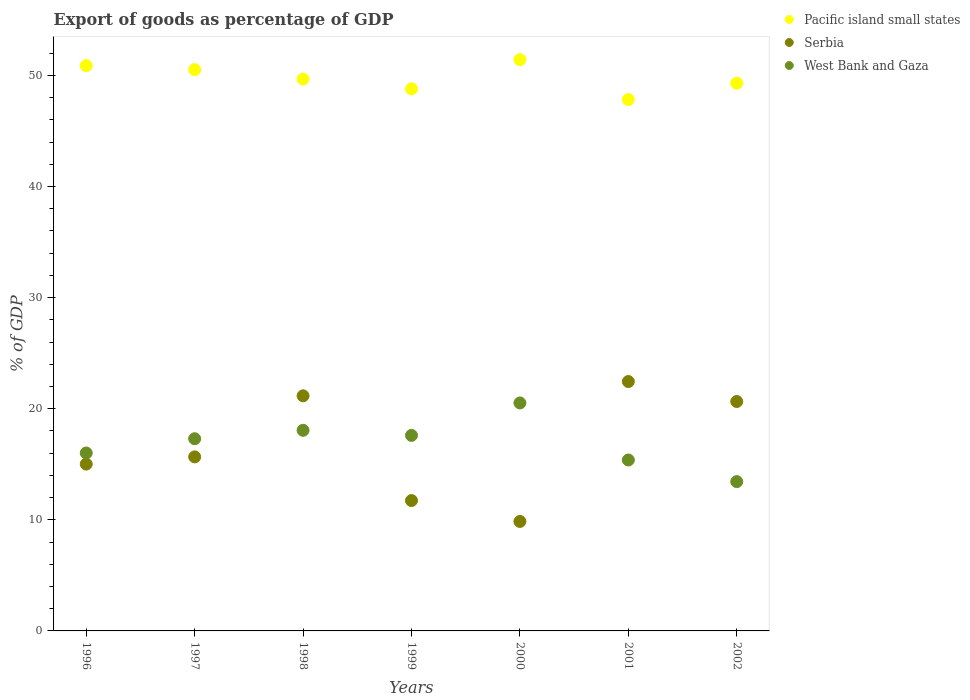How many different coloured dotlines are there?
Make the answer very short. 3. What is the export of goods as percentage of GDP in Pacific island small states in 2002?
Keep it short and to the point. 49.3. Across all years, what is the maximum export of goods as percentage of GDP in Serbia?
Provide a short and direct response. 22.44. Across all years, what is the minimum export of goods as percentage of GDP in West Bank and Gaza?
Ensure brevity in your answer.  13.44. In which year was the export of goods as percentage of GDP in Serbia minimum?
Offer a very short reply. 2000. What is the total export of goods as percentage of GDP in Pacific island small states in the graph?
Your answer should be very brief. 348.36. What is the difference between the export of goods as percentage of GDP in Pacific island small states in 1999 and that in 2001?
Ensure brevity in your answer.  0.96. What is the difference between the export of goods as percentage of GDP in Pacific island small states in 1997 and the export of goods as percentage of GDP in West Bank and Gaza in 1999?
Your answer should be very brief. 32.91. What is the average export of goods as percentage of GDP in West Bank and Gaza per year?
Provide a succinct answer. 16.9. In the year 2002, what is the difference between the export of goods as percentage of GDP in Serbia and export of goods as percentage of GDP in Pacific island small states?
Your answer should be very brief. -28.65. In how many years, is the export of goods as percentage of GDP in Serbia greater than 46 %?
Give a very brief answer. 0. What is the ratio of the export of goods as percentage of GDP in Serbia in 1996 to that in 1999?
Provide a short and direct response. 1.28. What is the difference between the highest and the second highest export of goods as percentage of GDP in Pacific island small states?
Provide a succinct answer. 0.54. What is the difference between the highest and the lowest export of goods as percentage of GDP in Serbia?
Offer a terse response. 12.59. In how many years, is the export of goods as percentage of GDP in West Bank and Gaza greater than the average export of goods as percentage of GDP in West Bank and Gaza taken over all years?
Ensure brevity in your answer.  4. Is it the case that in every year, the sum of the export of goods as percentage of GDP in Serbia and export of goods as percentage of GDP in West Bank and Gaza  is greater than the export of goods as percentage of GDP in Pacific island small states?
Provide a succinct answer. No. How many dotlines are there?
Your answer should be very brief. 3. How many years are there in the graph?
Your answer should be compact. 7. How many legend labels are there?
Make the answer very short. 3. What is the title of the graph?
Offer a very short reply. Export of goods as percentage of GDP. Does "Congo (Republic)" appear as one of the legend labels in the graph?
Your answer should be compact. No. What is the label or title of the Y-axis?
Give a very brief answer. % of GDP. What is the % of GDP in Pacific island small states in 1996?
Make the answer very short. 50.87. What is the % of GDP in Serbia in 1996?
Provide a short and direct response. 15.01. What is the % of GDP of West Bank and Gaza in 1996?
Offer a very short reply. 16.01. What is the % of GDP of Pacific island small states in 1997?
Give a very brief answer. 50.51. What is the % of GDP in Serbia in 1997?
Offer a terse response. 15.66. What is the % of GDP in West Bank and Gaza in 1997?
Give a very brief answer. 17.3. What is the % of GDP of Pacific island small states in 1998?
Keep it short and to the point. 49.67. What is the % of GDP of Serbia in 1998?
Keep it short and to the point. 21.16. What is the % of GDP in West Bank and Gaza in 1998?
Offer a terse response. 18.05. What is the % of GDP in Pacific island small states in 1999?
Make the answer very short. 48.78. What is the % of GDP in Serbia in 1999?
Your answer should be compact. 11.73. What is the % of GDP in West Bank and Gaza in 1999?
Keep it short and to the point. 17.6. What is the % of GDP in Pacific island small states in 2000?
Give a very brief answer. 51.41. What is the % of GDP in Serbia in 2000?
Offer a very short reply. 9.85. What is the % of GDP in West Bank and Gaza in 2000?
Offer a terse response. 20.52. What is the % of GDP in Pacific island small states in 2001?
Offer a terse response. 47.82. What is the % of GDP in Serbia in 2001?
Keep it short and to the point. 22.44. What is the % of GDP of West Bank and Gaza in 2001?
Provide a short and direct response. 15.38. What is the % of GDP in Pacific island small states in 2002?
Ensure brevity in your answer.  49.3. What is the % of GDP in Serbia in 2002?
Your answer should be compact. 20.65. What is the % of GDP in West Bank and Gaza in 2002?
Ensure brevity in your answer.  13.44. Across all years, what is the maximum % of GDP in Pacific island small states?
Your answer should be very brief. 51.41. Across all years, what is the maximum % of GDP in Serbia?
Provide a short and direct response. 22.44. Across all years, what is the maximum % of GDP in West Bank and Gaza?
Ensure brevity in your answer.  20.52. Across all years, what is the minimum % of GDP in Pacific island small states?
Give a very brief answer. 47.82. Across all years, what is the minimum % of GDP of Serbia?
Keep it short and to the point. 9.85. Across all years, what is the minimum % of GDP of West Bank and Gaza?
Give a very brief answer. 13.44. What is the total % of GDP in Pacific island small states in the graph?
Your answer should be compact. 348.36. What is the total % of GDP in Serbia in the graph?
Provide a succinct answer. 116.51. What is the total % of GDP of West Bank and Gaza in the graph?
Make the answer very short. 118.3. What is the difference between the % of GDP of Pacific island small states in 1996 and that in 1997?
Offer a very short reply. 0.36. What is the difference between the % of GDP in Serbia in 1996 and that in 1997?
Ensure brevity in your answer.  -0.65. What is the difference between the % of GDP of West Bank and Gaza in 1996 and that in 1997?
Your answer should be compact. -1.28. What is the difference between the % of GDP in Pacific island small states in 1996 and that in 1998?
Your answer should be very brief. 1.21. What is the difference between the % of GDP in Serbia in 1996 and that in 1998?
Your answer should be compact. -6.14. What is the difference between the % of GDP in West Bank and Gaza in 1996 and that in 1998?
Your answer should be compact. -2.04. What is the difference between the % of GDP in Pacific island small states in 1996 and that in 1999?
Your answer should be very brief. 2.09. What is the difference between the % of GDP of Serbia in 1996 and that in 1999?
Make the answer very short. 3.28. What is the difference between the % of GDP in West Bank and Gaza in 1996 and that in 1999?
Provide a succinct answer. -1.58. What is the difference between the % of GDP in Pacific island small states in 1996 and that in 2000?
Your answer should be compact. -0.54. What is the difference between the % of GDP in Serbia in 1996 and that in 2000?
Provide a succinct answer. 5.16. What is the difference between the % of GDP in West Bank and Gaza in 1996 and that in 2000?
Make the answer very short. -4.5. What is the difference between the % of GDP of Pacific island small states in 1996 and that in 2001?
Provide a succinct answer. 3.05. What is the difference between the % of GDP in Serbia in 1996 and that in 2001?
Ensure brevity in your answer.  -7.43. What is the difference between the % of GDP of West Bank and Gaza in 1996 and that in 2001?
Give a very brief answer. 0.63. What is the difference between the % of GDP of Pacific island small states in 1996 and that in 2002?
Your response must be concise. 1.57. What is the difference between the % of GDP of Serbia in 1996 and that in 2002?
Your answer should be compact. -5.63. What is the difference between the % of GDP of West Bank and Gaza in 1996 and that in 2002?
Make the answer very short. 2.58. What is the difference between the % of GDP of Pacific island small states in 1997 and that in 1998?
Make the answer very short. 0.85. What is the difference between the % of GDP in Serbia in 1997 and that in 1998?
Provide a short and direct response. -5.5. What is the difference between the % of GDP of West Bank and Gaza in 1997 and that in 1998?
Offer a terse response. -0.76. What is the difference between the % of GDP in Pacific island small states in 1997 and that in 1999?
Your answer should be compact. 1.73. What is the difference between the % of GDP of Serbia in 1997 and that in 1999?
Offer a very short reply. 3.93. What is the difference between the % of GDP of West Bank and Gaza in 1997 and that in 1999?
Keep it short and to the point. -0.3. What is the difference between the % of GDP of Pacific island small states in 1997 and that in 2000?
Ensure brevity in your answer.  -0.9. What is the difference between the % of GDP of Serbia in 1997 and that in 2000?
Your answer should be compact. 5.81. What is the difference between the % of GDP in West Bank and Gaza in 1997 and that in 2000?
Ensure brevity in your answer.  -3.22. What is the difference between the % of GDP of Pacific island small states in 1997 and that in 2001?
Provide a short and direct response. 2.69. What is the difference between the % of GDP of Serbia in 1997 and that in 2001?
Offer a very short reply. -6.78. What is the difference between the % of GDP in West Bank and Gaza in 1997 and that in 2001?
Ensure brevity in your answer.  1.91. What is the difference between the % of GDP in Pacific island small states in 1997 and that in 2002?
Your response must be concise. 1.21. What is the difference between the % of GDP in Serbia in 1997 and that in 2002?
Provide a succinct answer. -4.98. What is the difference between the % of GDP of West Bank and Gaza in 1997 and that in 2002?
Your response must be concise. 3.86. What is the difference between the % of GDP in Pacific island small states in 1998 and that in 1999?
Your response must be concise. 0.88. What is the difference between the % of GDP in Serbia in 1998 and that in 1999?
Give a very brief answer. 9.43. What is the difference between the % of GDP of West Bank and Gaza in 1998 and that in 1999?
Make the answer very short. 0.46. What is the difference between the % of GDP in Pacific island small states in 1998 and that in 2000?
Provide a short and direct response. -1.74. What is the difference between the % of GDP of Serbia in 1998 and that in 2000?
Keep it short and to the point. 11.3. What is the difference between the % of GDP in West Bank and Gaza in 1998 and that in 2000?
Ensure brevity in your answer.  -2.46. What is the difference between the % of GDP of Pacific island small states in 1998 and that in 2001?
Make the answer very short. 1.85. What is the difference between the % of GDP of Serbia in 1998 and that in 2001?
Provide a short and direct response. -1.29. What is the difference between the % of GDP of West Bank and Gaza in 1998 and that in 2001?
Your answer should be very brief. 2.67. What is the difference between the % of GDP in Pacific island small states in 1998 and that in 2002?
Give a very brief answer. 0.37. What is the difference between the % of GDP in Serbia in 1998 and that in 2002?
Make the answer very short. 0.51. What is the difference between the % of GDP of West Bank and Gaza in 1998 and that in 2002?
Ensure brevity in your answer.  4.62. What is the difference between the % of GDP in Pacific island small states in 1999 and that in 2000?
Your answer should be compact. -2.63. What is the difference between the % of GDP of Serbia in 1999 and that in 2000?
Offer a terse response. 1.88. What is the difference between the % of GDP in West Bank and Gaza in 1999 and that in 2000?
Make the answer very short. -2.92. What is the difference between the % of GDP of Pacific island small states in 1999 and that in 2001?
Provide a short and direct response. 0.96. What is the difference between the % of GDP of Serbia in 1999 and that in 2001?
Make the answer very short. -10.71. What is the difference between the % of GDP in West Bank and Gaza in 1999 and that in 2001?
Make the answer very short. 2.21. What is the difference between the % of GDP of Pacific island small states in 1999 and that in 2002?
Your answer should be compact. -0.51. What is the difference between the % of GDP in Serbia in 1999 and that in 2002?
Provide a succinct answer. -8.91. What is the difference between the % of GDP in West Bank and Gaza in 1999 and that in 2002?
Keep it short and to the point. 4.16. What is the difference between the % of GDP of Pacific island small states in 2000 and that in 2001?
Provide a short and direct response. 3.59. What is the difference between the % of GDP of Serbia in 2000 and that in 2001?
Provide a succinct answer. -12.59. What is the difference between the % of GDP of West Bank and Gaza in 2000 and that in 2001?
Offer a terse response. 5.13. What is the difference between the % of GDP in Pacific island small states in 2000 and that in 2002?
Provide a short and direct response. 2.11. What is the difference between the % of GDP in Serbia in 2000 and that in 2002?
Provide a short and direct response. -10.79. What is the difference between the % of GDP of West Bank and Gaza in 2000 and that in 2002?
Offer a very short reply. 7.08. What is the difference between the % of GDP in Pacific island small states in 2001 and that in 2002?
Your answer should be very brief. -1.48. What is the difference between the % of GDP in Serbia in 2001 and that in 2002?
Ensure brevity in your answer.  1.8. What is the difference between the % of GDP of West Bank and Gaza in 2001 and that in 2002?
Your answer should be very brief. 1.95. What is the difference between the % of GDP of Pacific island small states in 1996 and the % of GDP of Serbia in 1997?
Your answer should be compact. 35.21. What is the difference between the % of GDP of Pacific island small states in 1996 and the % of GDP of West Bank and Gaza in 1997?
Your answer should be very brief. 33.58. What is the difference between the % of GDP of Serbia in 1996 and the % of GDP of West Bank and Gaza in 1997?
Keep it short and to the point. -2.28. What is the difference between the % of GDP of Pacific island small states in 1996 and the % of GDP of Serbia in 1998?
Your response must be concise. 29.71. What is the difference between the % of GDP in Pacific island small states in 1996 and the % of GDP in West Bank and Gaza in 1998?
Give a very brief answer. 32.82. What is the difference between the % of GDP of Serbia in 1996 and the % of GDP of West Bank and Gaza in 1998?
Your answer should be very brief. -3.04. What is the difference between the % of GDP of Pacific island small states in 1996 and the % of GDP of Serbia in 1999?
Ensure brevity in your answer.  39.14. What is the difference between the % of GDP in Pacific island small states in 1996 and the % of GDP in West Bank and Gaza in 1999?
Ensure brevity in your answer.  33.27. What is the difference between the % of GDP of Serbia in 1996 and the % of GDP of West Bank and Gaza in 1999?
Your answer should be compact. -2.58. What is the difference between the % of GDP of Pacific island small states in 1996 and the % of GDP of Serbia in 2000?
Offer a very short reply. 41.02. What is the difference between the % of GDP of Pacific island small states in 1996 and the % of GDP of West Bank and Gaza in 2000?
Your answer should be compact. 30.36. What is the difference between the % of GDP of Serbia in 1996 and the % of GDP of West Bank and Gaza in 2000?
Give a very brief answer. -5.5. What is the difference between the % of GDP of Pacific island small states in 1996 and the % of GDP of Serbia in 2001?
Your answer should be very brief. 28.43. What is the difference between the % of GDP of Pacific island small states in 1996 and the % of GDP of West Bank and Gaza in 2001?
Your answer should be compact. 35.49. What is the difference between the % of GDP in Serbia in 1996 and the % of GDP in West Bank and Gaza in 2001?
Your answer should be compact. -0.37. What is the difference between the % of GDP in Pacific island small states in 1996 and the % of GDP in Serbia in 2002?
Your response must be concise. 30.23. What is the difference between the % of GDP in Pacific island small states in 1996 and the % of GDP in West Bank and Gaza in 2002?
Your answer should be compact. 37.43. What is the difference between the % of GDP of Serbia in 1996 and the % of GDP of West Bank and Gaza in 2002?
Offer a very short reply. 1.58. What is the difference between the % of GDP of Pacific island small states in 1997 and the % of GDP of Serbia in 1998?
Give a very brief answer. 29.35. What is the difference between the % of GDP in Pacific island small states in 1997 and the % of GDP in West Bank and Gaza in 1998?
Your answer should be very brief. 32.46. What is the difference between the % of GDP of Serbia in 1997 and the % of GDP of West Bank and Gaza in 1998?
Offer a very short reply. -2.39. What is the difference between the % of GDP in Pacific island small states in 1997 and the % of GDP in Serbia in 1999?
Your answer should be very brief. 38.78. What is the difference between the % of GDP in Pacific island small states in 1997 and the % of GDP in West Bank and Gaza in 1999?
Offer a very short reply. 32.91. What is the difference between the % of GDP of Serbia in 1997 and the % of GDP of West Bank and Gaza in 1999?
Provide a short and direct response. -1.93. What is the difference between the % of GDP of Pacific island small states in 1997 and the % of GDP of Serbia in 2000?
Offer a terse response. 40.66. What is the difference between the % of GDP in Pacific island small states in 1997 and the % of GDP in West Bank and Gaza in 2000?
Your answer should be compact. 30. What is the difference between the % of GDP of Serbia in 1997 and the % of GDP of West Bank and Gaza in 2000?
Make the answer very short. -4.85. What is the difference between the % of GDP of Pacific island small states in 1997 and the % of GDP of Serbia in 2001?
Make the answer very short. 28.07. What is the difference between the % of GDP in Pacific island small states in 1997 and the % of GDP in West Bank and Gaza in 2001?
Offer a very short reply. 35.13. What is the difference between the % of GDP of Serbia in 1997 and the % of GDP of West Bank and Gaza in 2001?
Ensure brevity in your answer.  0.28. What is the difference between the % of GDP of Pacific island small states in 1997 and the % of GDP of Serbia in 2002?
Ensure brevity in your answer.  29.87. What is the difference between the % of GDP of Pacific island small states in 1997 and the % of GDP of West Bank and Gaza in 2002?
Offer a very short reply. 37.07. What is the difference between the % of GDP of Serbia in 1997 and the % of GDP of West Bank and Gaza in 2002?
Your answer should be very brief. 2.23. What is the difference between the % of GDP of Pacific island small states in 1998 and the % of GDP of Serbia in 1999?
Your response must be concise. 37.93. What is the difference between the % of GDP of Pacific island small states in 1998 and the % of GDP of West Bank and Gaza in 1999?
Offer a very short reply. 32.07. What is the difference between the % of GDP of Serbia in 1998 and the % of GDP of West Bank and Gaza in 1999?
Offer a very short reply. 3.56. What is the difference between the % of GDP in Pacific island small states in 1998 and the % of GDP in Serbia in 2000?
Ensure brevity in your answer.  39.81. What is the difference between the % of GDP in Pacific island small states in 1998 and the % of GDP in West Bank and Gaza in 2000?
Give a very brief answer. 29.15. What is the difference between the % of GDP in Serbia in 1998 and the % of GDP in West Bank and Gaza in 2000?
Give a very brief answer. 0.64. What is the difference between the % of GDP of Pacific island small states in 1998 and the % of GDP of Serbia in 2001?
Give a very brief answer. 27.22. What is the difference between the % of GDP of Pacific island small states in 1998 and the % of GDP of West Bank and Gaza in 2001?
Offer a terse response. 34.28. What is the difference between the % of GDP of Serbia in 1998 and the % of GDP of West Bank and Gaza in 2001?
Offer a very short reply. 5.77. What is the difference between the % of GDP of Pacific island small states in 1998 and the % of GDP of Serbia in 2002?
Ensure brevity in your answer.  29.02. What is the difference between the % of GDP in Pacific island small states in 1998 and the % of GDP in West Bank and Gaza in 2002?
Keep it short and to the point. 36.23. What is the difference between the % of GDP in Serbia in 1998 and the % of GDP in West Bank and Gaza in 2002?
Your answer should be compact. 7.72. What is the difference between the % of GDP in Pacific island small states in 1999 and the % of GDP in Serbia in 2000?
Keep it short and to the point. 38.93. What is the difference between the % of GDP of Pacific island small states in 1999 and the % of GDP of West Bank and Gaza in 2000?
Offer a terse response. 28.27. What is the difference between the % of GDP in Serbia in 1999 and the % of GDP in West Bank and Gaza in 2000?
Offer a very short reply. -8.78. What is the difference between the % of GDP in Pacific island small states in 1999 and the % of GDP in Serbia in 2001?
Offer a terse response. 26.34. What is the difference between the % of GDP of Pacific island small states in 1999 and the % of GDP of West Bank and Gaza in 2001?
Offer a terse response. 33.4. What is the difference between the % of GDP of Serbia in 1999 and the % of GDP of West Bank and Gaza in 2001?
Your answer should be compact. -3.65. What is the difference between the % of GDP of Pacific island small states in 1999 and the % of GDP of Serbia in 2002?
Your response must be concise. 28.14. What is the difference between the % of GDP in Pacific island small states in 1999 and the % of GDP in West Bank and Gaza in 2002?
Keep it short and to the point. 35.35. What is the difference between the % of GDP in Serbia in 1999 and the % of GDP in West Bank and Gaza in 2002?
Offer a very short reply. -1.7. What is the difference between the % of GDP of Pacific island small states in 2000 and the % of GDP of Serbia in 2001?
Give a very brief answer. 28.97. What is the difference between the % of GDP in Pacific island small states in 2000 and the % of GDP in West Bank and Gaza in 2001?
Make the answer very short. 36.03. What is the difference between the % of GDP of Serbia in 2000 and the % of GDP of West Bank and Gaza in 2001?
Keep it short and to the point. -5.53. What is the difference between the % of GDP of Pacific island small states in 2000 and the % of GDP of Serbia in 2002?
Your answer should be very brief. 30.77. What is the difference between the % of GDP of Pacific island small states in 2000 and the % of GDP of West Bank and Gaza in 2002?
Your response must be concise. 37.97. What is the difference between the % of GDP in Serbia in 2000 and the % of GDP in West Bank and Gaza in 2002?
Give a very brief answer. -3.58. What is the difference between the % of GDP of Pacific island small states in 2001 and the % of GDP of Serbia in 2002?
Your response must be concise. 27.18. What is the difference between the % of GDP of Pacific island small states in 2001 and the % of GDP of West Bank and Gaza in 2002?
Provide a short and direct response. 34.38. What is the difference between the % of GDP in Serbia in 2001 and the % of GDP in West Bank and Gaza in 2002?
Ensure brevity in your answer.  9.01. What is the average % of GDP in Pacific island small states per year?
Keep it short and to the point. 49.77. What is the average % of GDP in Serbia per year?
Make the answer very short. 16.64. What is the average % of GDP in West Bank and Gaza per year?
Your answer should be very brief. 16.9. In the year 1996, what is the difference between the % of GDP in Pacific island small states and % of GDP in Serbia?
Your answer should be compact. 35.86. In the year 1996, what is the difference between the % of GDP of Pacific island small states and % of GDP of West Bank and Gaza?
Make the answer very short. 34.86. In the year 1996, what is the difference between the % of GDP in Serbia and % of GDP in West Bank and Gaza?
Ensure brevity in your answer.  -1. In the year 1997, what is the difference between the % of GDP of Pacific island small states and % of GDP of Serbia?
Offer a very short reply. 34.85. In the year 1997, what is the difference between the % of GDP in Pacific island small states and % of GDP in West Bank and Gaza?
Keep it short and to the point. 33.22. In the year 1997, what is the difference between the % of GDP of Serbia and % of GDP of West Bank and Gaza?
Keep it short and to the point. -1.63. In the year 1998, what is the difference between the % of GDP in Pacific island small states and % of GDP in Serbia?
Your response must be concise. 28.51. In the year 1998, what is the difference between the % of GDP in Pacific island small states and % of GDP in West Bank and Gaza?
Provide a short and direct response. 31.61. In the year 1998, what is the difference between the % of GDP of Serbia and % of GDP of West Bank and Gaza?
Offer a very short reply. 3.1. In the year 1999, what is the difference between the % of GDP of Pacific island small states and % of GDP of Serbia?
Ensure brevity in your answer.  37.05. In the year 1999, what is the difference between the % of GDP of Pacific island small states and % of GDP of West Bank and Gaza?
Your answer should be compact. 31.19. In the year 1999, what is the difference between the % of GDP in Serbia and % of GDP in West Bank and Gaza?
Your answer should be compact. -5.86. In the year 2000, what is the difference between the % of GDP in Pacific island small states and % of GDP in Serbia?
Make the answer very short. 41.56. In the year 2000, what is the difference between the % of GDP of Pacific island small states and % of GDP of West Bank and Gaza?
Your answer should be compact. 30.89. In the year 2000, what is the difference between the % of GDP of Serbia and % of GDP of West Bank and Gaza?
Offer a very short reply. -10.66. In the year 2001, what is the difference between the % of GDP of Pacific island small states and % of GDP of Serbia?
Make the answer very short. 25.38. In the year 2001, what is the difference between the % of GDP of Pacific island small states and % of GDP of West Bank and Gaza?
Your answer should be compact. 32.44. In the year 2001, what is the difference between the % of GDP of Serbia and % of GDP of West Bank and Gaza?
Ensure brevity in your answer.  7.06. In the year 2002, what is the difference between the % of GDP of Pacific island small states and % of GDP of Serbia?
Keep it short and to the point. 28.65. In the year 2002, what is the difference between the % of GDP of Pacific island small states and % of GDP of West Bank and Gaza?
Provide a succinct answer. 35.86. In the year 2002, what is the difference between the % of GDP in Serbia and % of GDP in West Bank and Gaza?
Your response must be concise. 7.21. What is the ratio of the % of GDP in Pacific island small states in 1996 to that in 1997?
Give a very brief answer. 1.01. What is the ratio of the % of GDP in Serbia in 1996 to that in 1997?
Keep it short and to the point. 0.96. What is the ratio of the % of GDP in West Bank and Gaza in 1996 to that in 1997?
Offer a terse response. 0.93. What is the ratio of the % of GDP in Pacific island small states in 1996 to that in 1998?
Keep it short and to the point. 1.02. What is the ratio of the % of GDP in Serbia in 1996 to that in 1998?
Your answer should be compact. 0.71. What is the ratio of the % of GDP of West Bank and Gaza in 1996 to that in 1998?
Your answer should be very brief. 0.89. What is the ratio of the % of GDP of Pacific island small states in 1996 to that in 1999?
Provide a succinct answer. 1.04. What is the ratio of the % of GDP of Serbia in 1996 to that in 1999?
Offer a very short reply. 1.28. What is the ratio of the % of GDP in West Bank and Gaza in 1996 to that in 1999?
Ensure brevity in your answer.  0.91. What is the ratio of the % of GDP in Pacific island small states in 1996 to that in 2000?
Provide a short and direct response. 0.99. What is the ratio of the % of GDP in Serbia in 1996 to that in 2000?
Keep it short and to the point. 1.52. What is the ratio of the % of GDP in West Bank and Gaza in 1996 to that in 2000?
Provide a short and direct response. 0.78. What is the ratio of the % of GDP in Pacific island small states in 1996 to that in 2001?
Provide a short and direct response. 1.06. What is the ratio of the % of GDP of Serbia in 1996 to that in 2001?
Ensure brevity in your answer.  0.67. What is the ratio of the % of GDP of West Bank and Gaza in 1996 to that in 2001?
Ensure brevity in your answer.  1.04. What is the ratio of the % of GDP in Pacific island small states in 1996 to that in 2002?
Provide a short and direct response. 1.03. What is the ratio of the % of GDP in Serbia in 1996 to that in 2002?
Give a very brief answer. 0.73. What is the ratio of the % of GDP of West Bank and Gaza in 1996 to that in 2002?
Give a very brief answer. 1.19. What is the ratio of the % of GDP of Pacific island small states in 1997 to that in 1998?
Provide a short and direct response. 1.02. What is the ratio of the % of GDP in Serbia in 1997 to that in 1998?
Give a very brief answer. 0.74. What is the ratio of the % of GDP in West Bank and Gaza in 1997 to that in 1998?
Your answer should be very brief. 0.96. What is the ratio of the % of GDP of Pacific island small states in 1997 to that in 1999?
Make the answer very short. 1.04. What is the ratio of the % of GDP in Serbia in 1997 to that in 1999?
Your response must be concise. 1.33. What is the ratio of the % of GDP in West Bank and Gaza in 1997 to that in 1999?
Ensure brevity in your answer.  0.98. What is the ratio of the % of GDP of Pacific island small states in 1997 to that in 2000?
Provide a short and direct response. 0.98. What is the ratio of the % of GDP of Serbia in 1997 to that in 2000?
Your answer should be very brief. 1.59. What is the ratio of the % of GDP in West Bank and Gaza in 1997 to that in 2000?
Your answer should be very brief. 0.84. What is the ratio of the % of GDP of Pacific island small states in 1997 to that in 2001?
Offer a terse response. 1.06. What is the ratio of the % of GDP of Serbia in 1997 to that in 2001?
Offer a very short reply. 0.7. What is the ratio of the % of GDP of West Bank and Gaza in 1997 to that in 2001?
Offer a terse response. 1.12. What is the ratio of the % of GDP in Pacific island small states in 1997 to that in 2002?
Your answer should be very brief. 1.02. What is the ratio of the % of GDP of Serbia in 1997 to that in 2002?
Your response must be concise. 0.76. What is the ratio of the % of GDP of West Bank and Gaza in 1997 to that in 2002?
Give a very brief answer. 1.29. What is the ratio of the % of GDP of Pacific island small states in 1998 to that in 1999?
Give a very brief answer. 1.02. What is the ratio of the % of GDP in Serbia in 1998 to that in 1999?
Your answer should be compact. 1.8. What is the ratio of the % of GDP in Pacific island small states in 1998 to that in 2000?
Provide a short and direct response. 0.97. What is the ratio of the % of GDP of Serbia in 1998 to that in 2000?
Provide a short and direct response. 2.15. What is the ratio of the % of GDP of West Bank and Gaza in 1998 to that in 2000?
Your response must be concise. 0.88. What is the ratio of the % of GDP in Pacific island small states in 1998 to that in 2001?
Your response must be concise. 1.04. What is the ratio of the % of GDP of Serbia in 1998 to that in 2001?
Ensure brevity in your answer.  0.94. What is the ratio of the % of GDP in West Bank and Gaza in 1998 to that in 2001?
Offer a terse response. 1.17. What is the ratio of the % of GDP of Pacific island small states in 1998 to that in 2002?
Offer a very short reply. 1.01. What is the ratio of the % of GDP in Serbia in 1998 to that in 2002?
Provide a short and direct response. 1.02. What is the ratio of the % of GDP of West Bank and Gaza in 1998 to that in 2002?
Provide a succinct answer. 1.34. What is the ratio of the % of GDP in Pacific island small states in 1999 to that in 2000?
Provide a succinct answer. 0.95. What is the ratio of the % of GDP of Serbia in 1999 to that in 2000?
Offer a very short reply. 1.19. What is the ratio of the % of GDP in West Bank and Gaza in 1999 to that in 2000?
Provide a succinct answer. 0.86. What is the ratio of the % of GDP in Pacific island small states in 1999 to that in 2001?
Provide a succinct answer. 1.02. What is the ratio of the % of GDP in Serbia in 1999 to that in 2001?
Keep it short and to the point. 0.52. What is the ratio of the % of GDP in West Bank and Gaza in 1999 to that in 2001?
Your response must be concise. 1.14. What is the ratio of the % of GDP of Serbia in 1999 to that in 2002?
Provide a short and direct response. 0.57. What is the ratio of the % of GDP of West Bank and Gaza in 1999 to that in 2002?
Your response must be concise. 1.31. What is the ratio of the % of GDP of Pacific island small states in 2000 to that in 2001?
Your answer should be compact. 1.08. What is the ratio of the % of GDP in Serbia in 2000 to that in 2001?
Keep it short and to the point. 0.44. What is the ratio of the % of GDP of West Bank and Gaza in 2000 to that in 2001?
Offer a very short reply. 1.33. What is the ratio of the % of GDP in Pacific island small states in 2000 to that in 2002?
Ensure brevity in your answer.  1.04. What is the ratio of the % of GDP of Serbia in 2000 to that in 2002?
Provide a succinct answer. 0.48. What is the ratio of the % of GDP in West Bank and Gaza in 2000 to that in 2002?
Your answer should be very brief. 1.53. What is the ratio of the % of GDP in Pacific island small states in 2001 to that in 2002?
Your answer should be very brief. 0.97. What is the ratio of the % of GDP in Serbia in 2001 to that in 2002?
Give a very brief answer. 1.09. What is the ratio of the % of GDP in West Bank and Gaza in 2001 to that in 2002?
Provide a short and direct response. 1.14. What is the difference between the highest and the second highest % of GDP in Pacific island small states?
Offer a very short reply. 0.54. What is the difference between the highest and the second highest % of GDP of Serbia?
Your answer should be very brief. 1.29. What is the difference between the highest and the second highest % of GDP of West Bank and Gaza?
Give a very brief answer. 2.46. What is the difference between the highest and the lowest % of GDP of Pacific island small states?
Offer a terse response. 3.59. What is the difference between the highest and the lowest % of GDP of Serbia?
Your response must be concise. 12.59. What is the difference between the highest and the lowest % of GDP in West Bank and Gaza?
Ensure brevity in your answer.  7.08. 